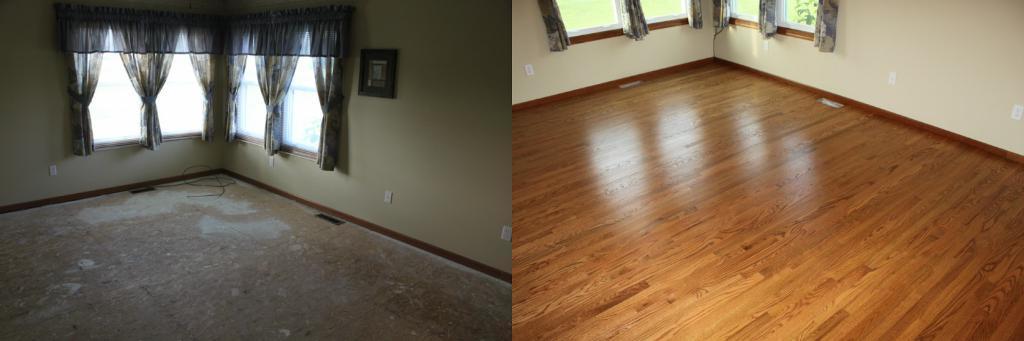Describe this image in one or two sentences. There are two images. On the left image there are windows with curtains. On the wall there is a frame. On the right image there are windows with curtains. And there is a wooden floor. 